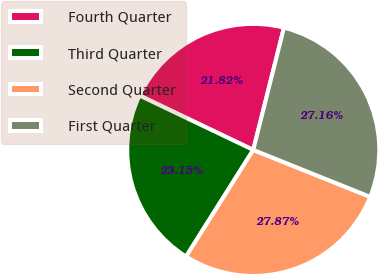<chart> <loc_0><loc_0><loc_500><loc_500><pie_chart><fcel>Fourth Quarter<fcel>Third Quarter<fcel>Second Quarter<fcel>First Quarter<nl><fcel>21.82%<fcel>23.15%<fcel>27.87%<fcel>27.16%<nl></chart> 